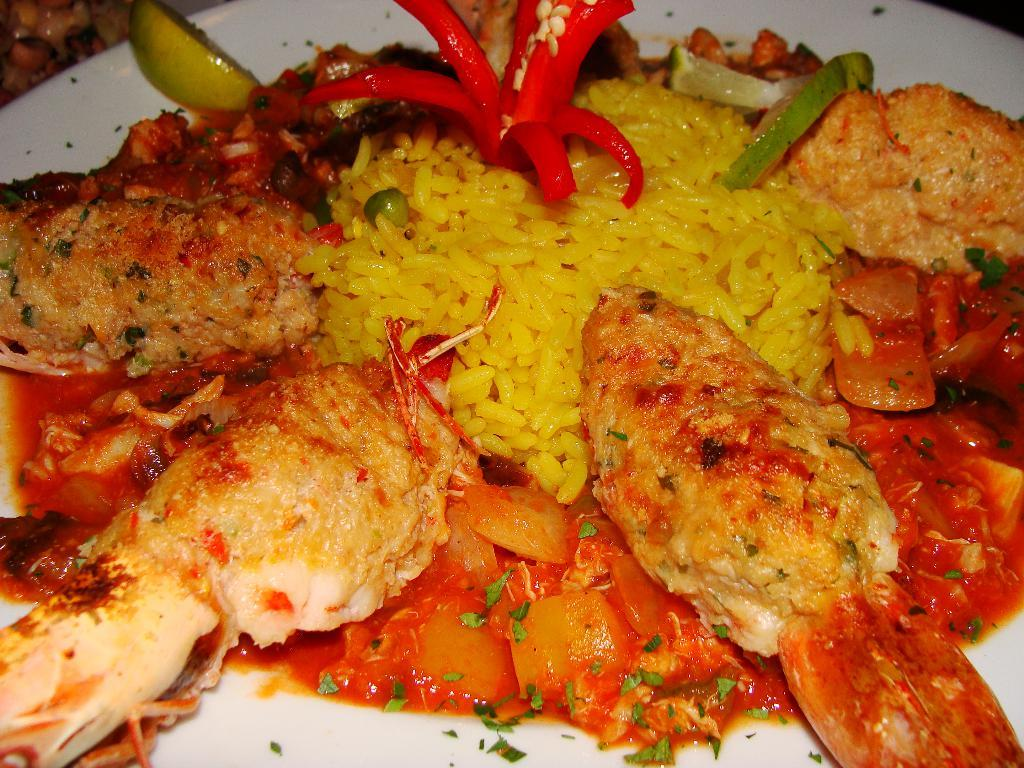What is present in the image? There are food items in the image. How are the food items arranged or presented? The food items are placed on a white plate. What type of net can be seen holding the food items in the image? There is no net present in the image; the food items are placed on a white plate. How many people are visible in the image, forming a crowd around the food items? There are no people visible in the image; it only shows food items on a white plate. 